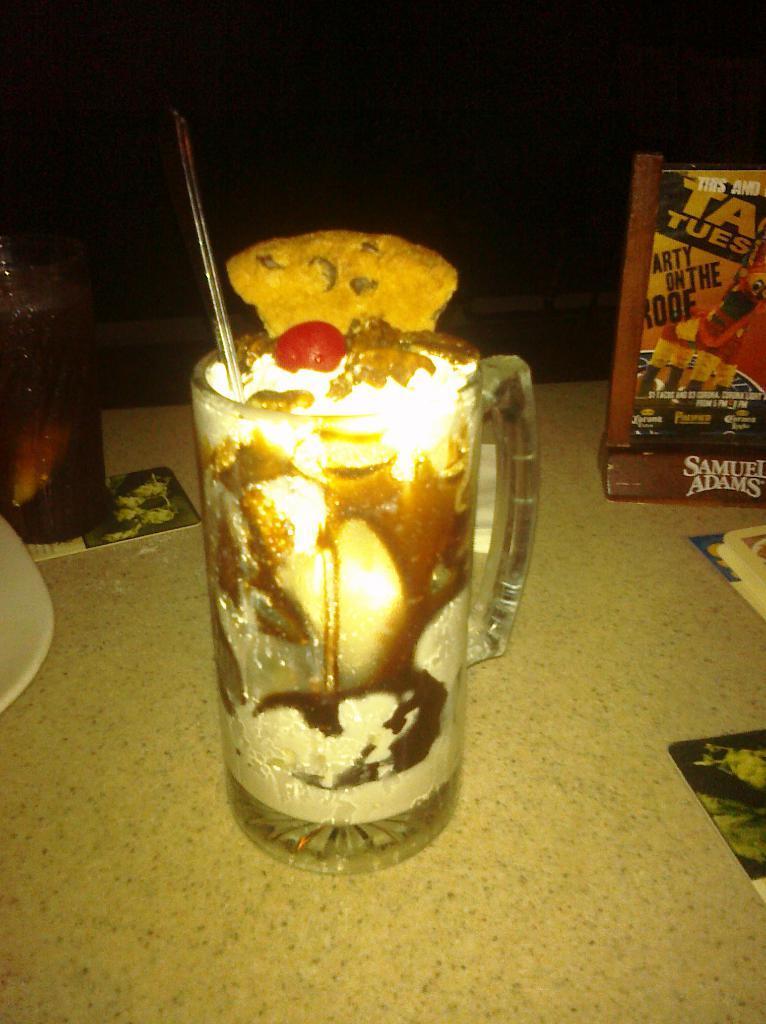How would you summarize this image in a sentence or two? In this image I can see a glass and in it I can see a red colour thing, a piece of cookie and other things. I can also see something is written in background and I can see this image is little bit in dark. 